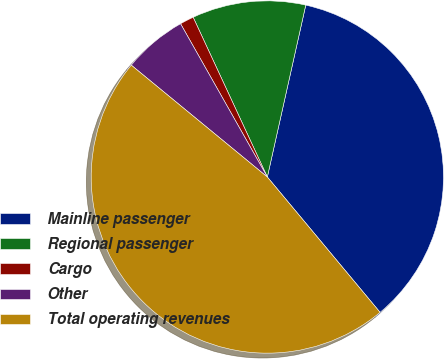<chart> <loc_0><loc_0><loc_500><loc_500><pie_chart><fcel>Mainline passenger<fcel>Regional passenger<fcel>Cargo<fcel>Other<fcel>Total operating revenues<nl><fcel>35.45%<fcel>10.42%<fcel>1.28%<fcel>5.85%<fcel>47.01%<nl></chart> 